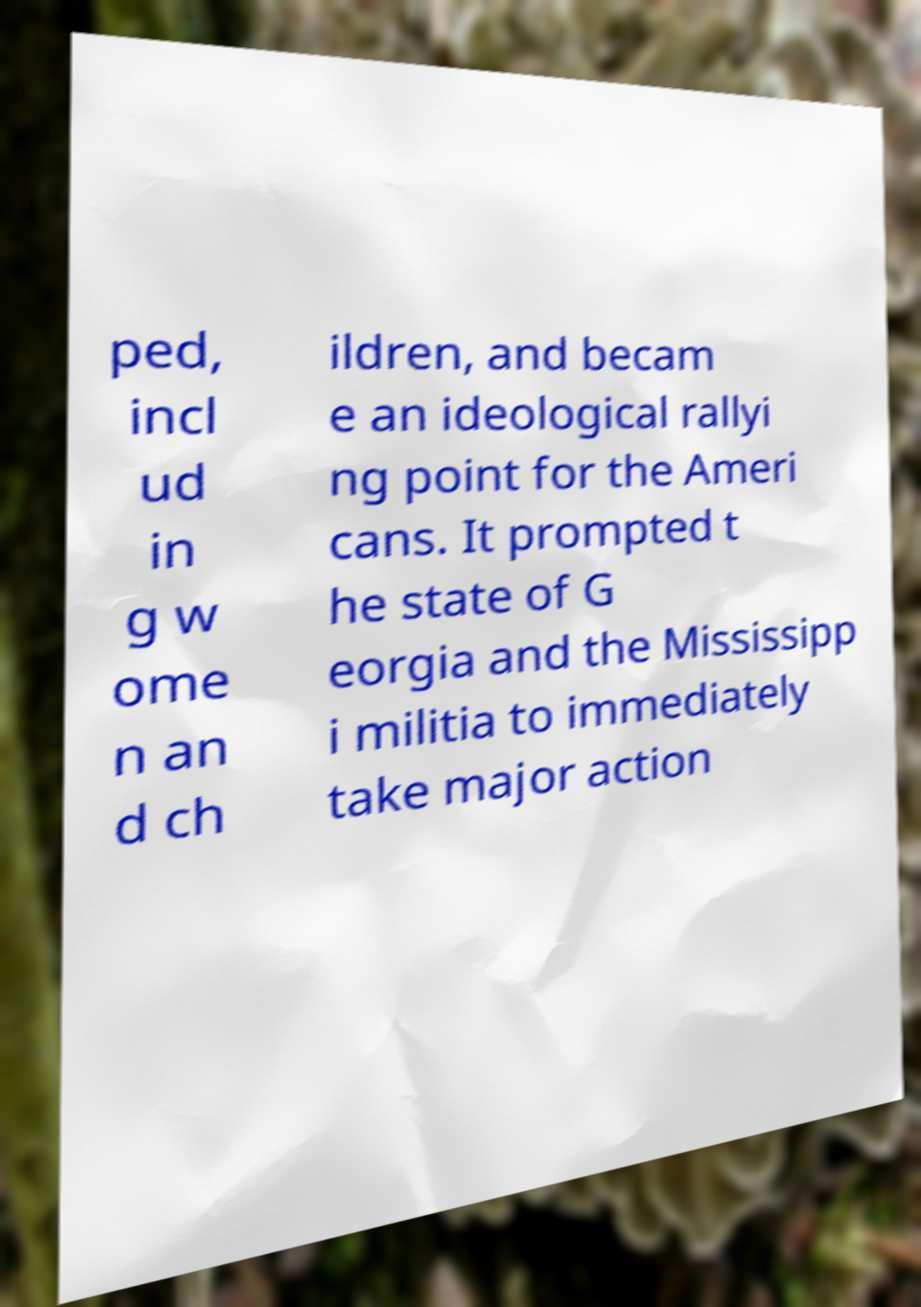Please identify and transcribe the text found in this image. ped, incl ud in g w ome n an d ch ildren, and becam e an ideological rallyi ng point for the Ameri cans. It prompted t he state of G eorgia and the Mississipp i militia to immediately take major action 